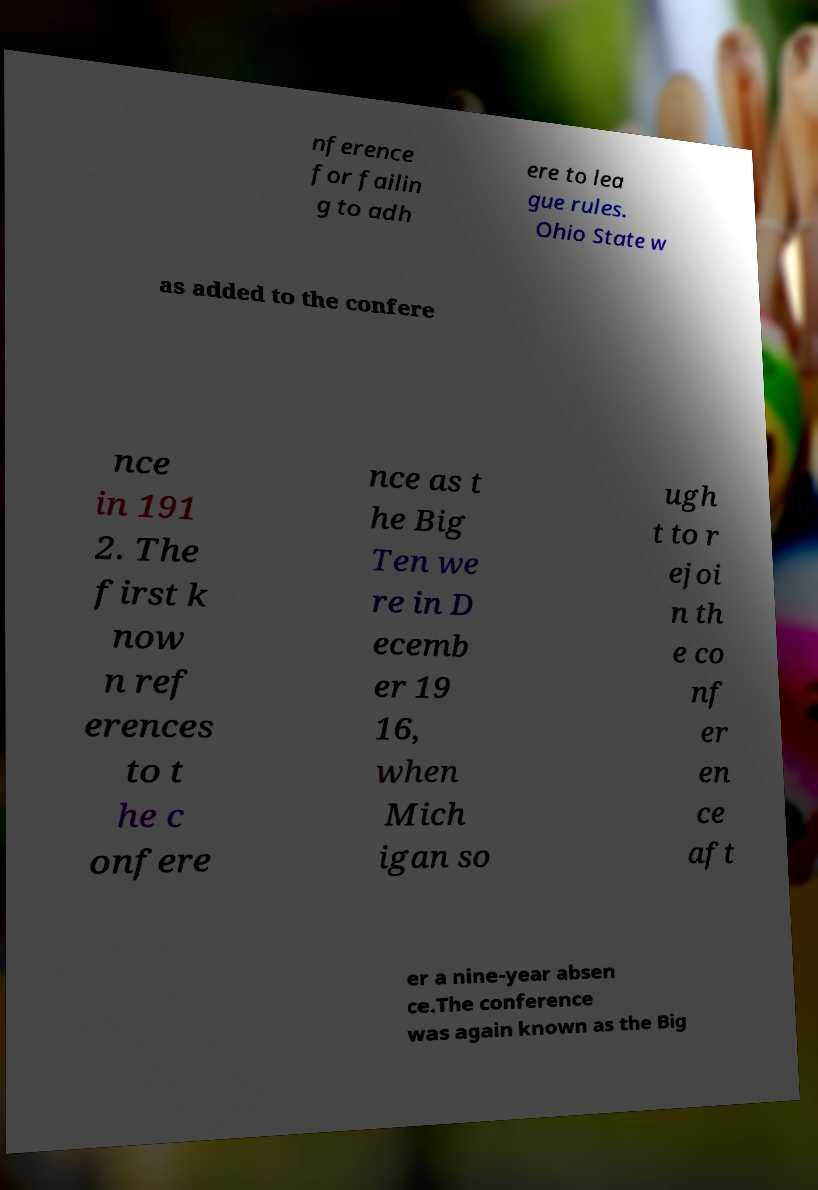Could you extract and type out the text from this image? nference for failin g to adh ere to lea gue rules. Ohio State w as added to the confere nce in 191 2. The first k now n ref erences to t he c onfere nce as t he Big Ten we re in D ecemb er 19 16, when Mich igan so ugh t to r ejoi n th e co nf er en ce aft er a nine-year absen ce.The conference was again known as the Big 